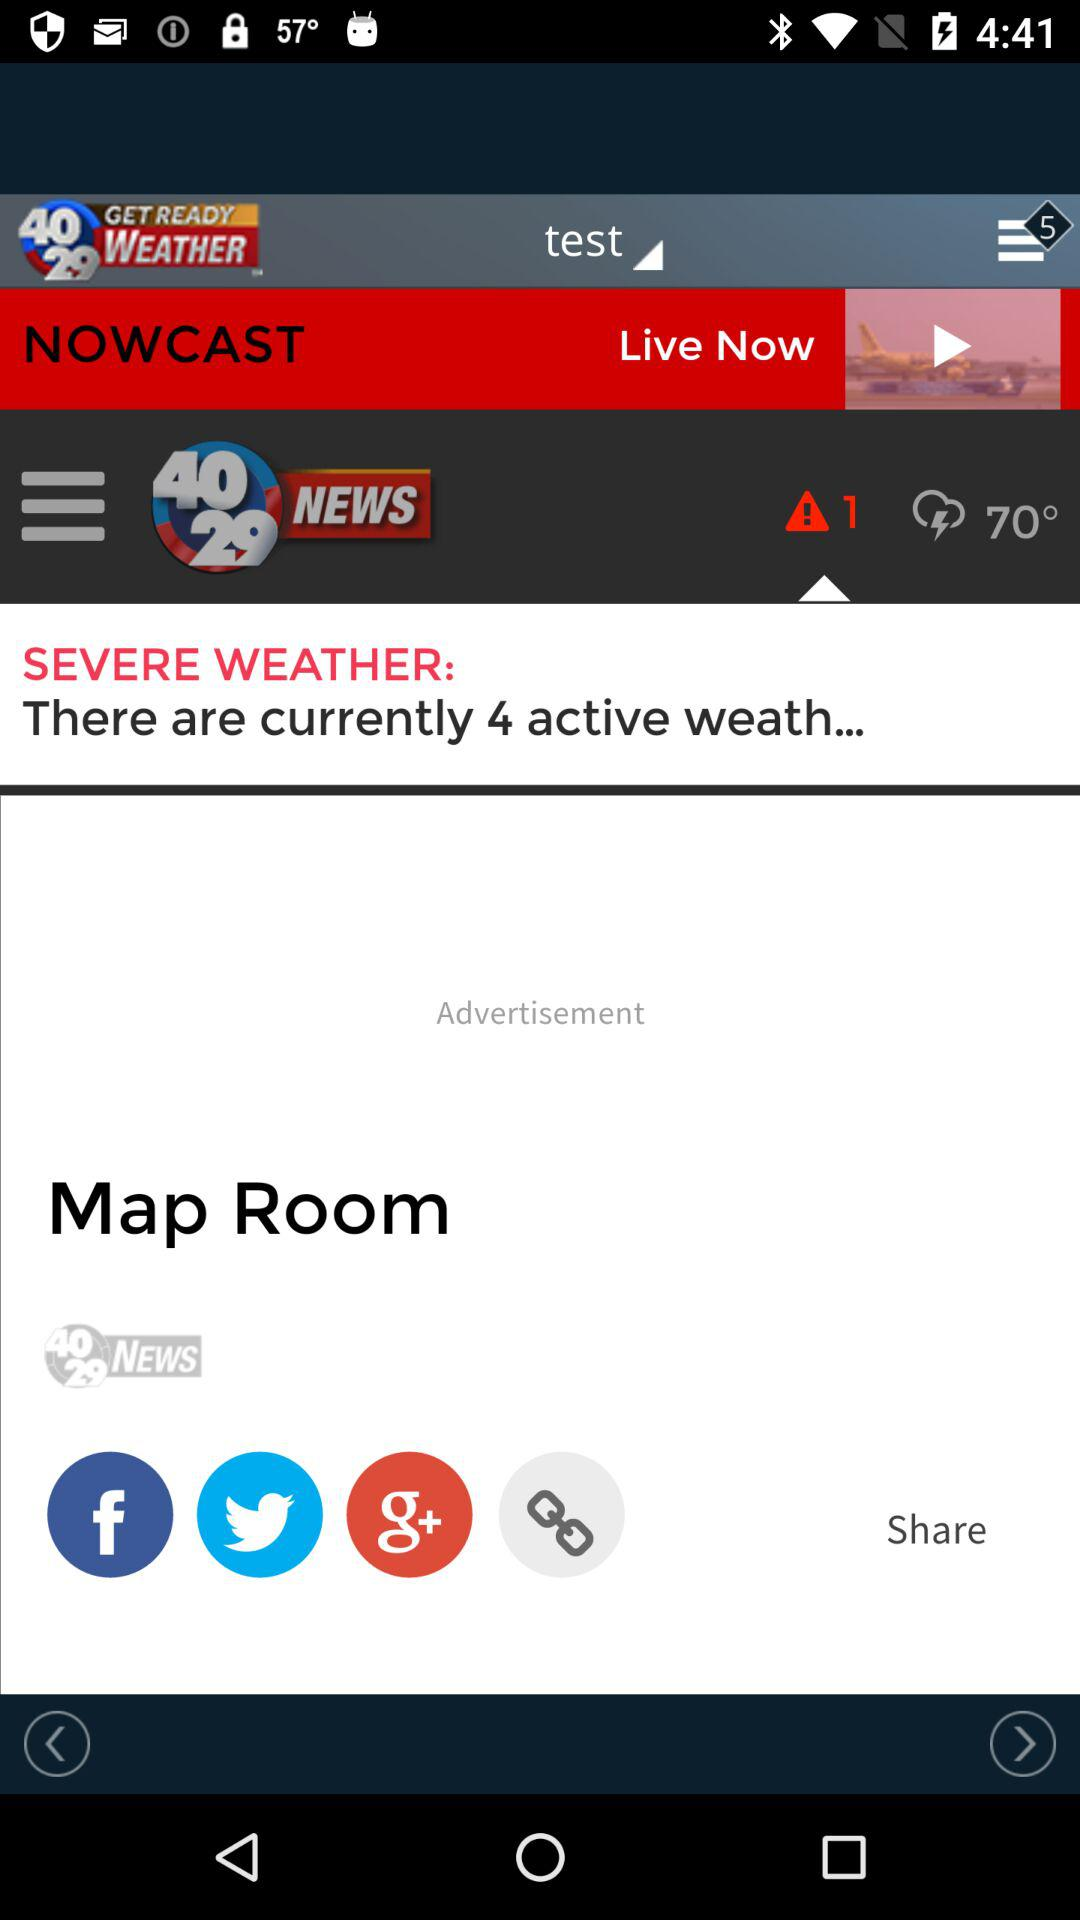What's the number of currently active weather? The number of currently active weather is 4. 